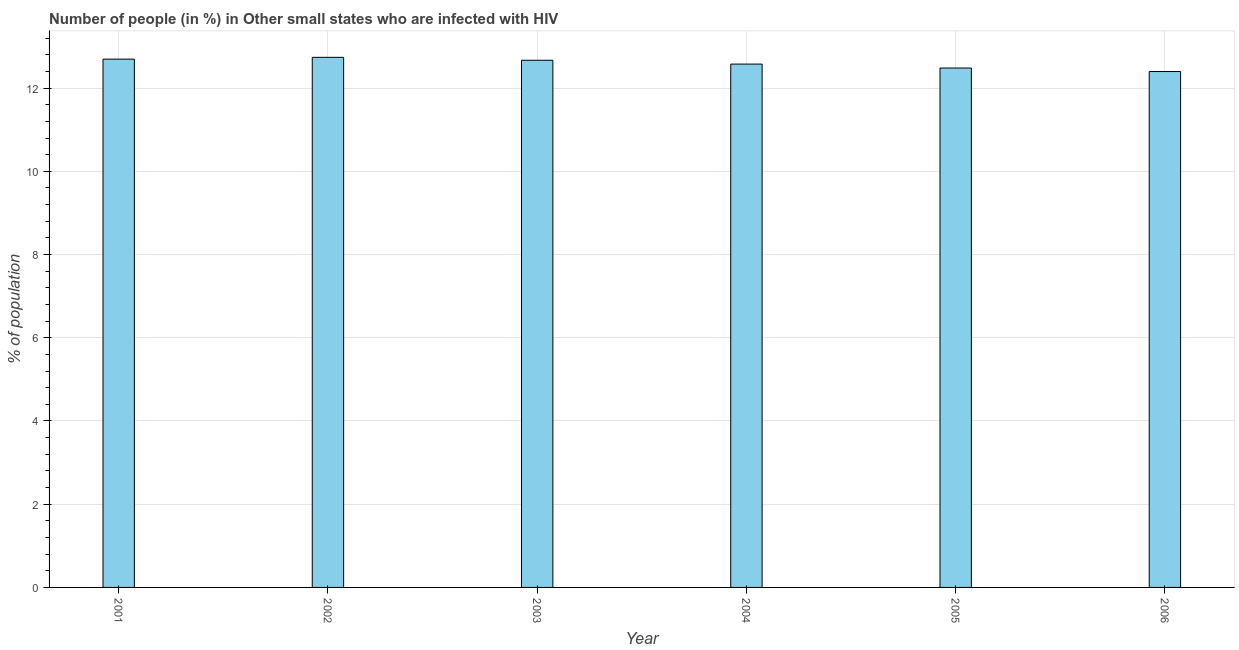Does the graph contain grids?
Keep it short and to the point. Yes. What is the title of the graph?
Ensure brevity in your answer.  Number of people (in %) in Other small states who are infected with HIV. What is the label or title of the X-axis?
Ensure brevity in your answer.  Year. What is the label or title of the Y-axis?
Provide a short and direct response. % of population. What is the number of people infected with hiv in 2001?
Your response must be concise. 12.7. Across all years, what is the maximum number of people infected with hiv?
Ensure brevity in your answer.  12.74. Across all years, what is the minimum number of people infected with hiv?
Your answer should be very brief. 12.4. In which year was the number of people infected with hiv minimum?
Your answer should be compact. 2006. What is the sum of the number of people infected with hiv?
Your answer should be compact. 75.56. What is the difference between the number of people infected with hiv in 2005 and 2006?
Your answer should be compact. 0.08. What is the average number of people infected with hiv per year?
Give a very brief answer. 12.59. What is the median number of people infected with hiv?
Provide a succinct answer. 12.62. In how many years, is the number of people infected with hiv greater than 4.4 %?
Ensure brevity in your answer.  6. Is the number of people infected with hiv in 2004 less than that in 2005?
Ensure brevity in your answer.  No. Is the difference between the number of people infected with hiv in 2001 and 2006 greater than the difference between any two years?
Make the answer very short. No. What is the difference between the highest and the second highest number of people infected with hiv?
Ensure brevity in your answer.  0.04. What is the difference between the highest and the lowest number of people infected with hiv?
Your answer should be very brief. 0.34. In how many years, is the number of people infected with hiv greater than the average number of people infected with hiv taken over all years?
Your answer should be very brief. 3. How many bars are there?
Make the answer very short. 6. Are all the bars in the graph horizontal?
Provide a short and direct response. No. How many years are there in the graph?
Provide a short and direct response. 6. What is the difference between two consecutive major ticks on the Y-axis?
Offer a very short reply. 2. What is the % of population of 2001?
Ensure brevity in your answer.  12.7. What is the % of population in 2002?
Your response must be concise. 12.74. What is the % of population of 2003?
Offer a terse response. 12.67. What is the % of population in 2004?
Provide a succinct answer. 12.58. What is the % of population in 2005?
Ensure brevity in your answer.  12.48. What is the % of population of 2006?
Give a very brief answer. 12.4. What is the difference between the % of population in 2001 and 2002?
Offer a terse response. -0.04. What is the difference between the % of population in 2001 and 2003?
Offer a terse response. 0.03. What is the difference between the % of population in 2001 and 2004?
Provide a short and direct response. 0.12. What is the difference between the % of population in 2001 and 2005?
Provide a succinct answer. 0.21. What is the difference between the % of population in 2001 and 2006?
Your answer should be compact. 0.3. What is the difference between the % of population in 2002 and 2003?
Keep it short and to the point. 0.07. What is the difference between the % of population in 2002 and 2004?
Your response must be concise. 0.16. What is the difference between the % of population in 2002 and 2005?
Make the answer very short. 0.26. What is the difference between the % of population in 2002 and 2006?
Offer a terse response. 0.34. What is the difference between the % of population in 2003 and 2004?
Provide a short and direct response. 0.09. What is the difference between the % of population in 2003 and 2005?
Keep it short and to the point. 0.19. What is the difference between the % of population in 2003 and 2006?
Your response must be concise. 0.27. What is the difference between the % of population in 2004 and 2005?
Offer a terse response. 0.09. What is the difference between the % of population in 2004 and 2006?
Your response must be concise. 0.18. What is the difference between the % of population in 2005 and 2006?
Offer a very short reply. 0.08. What is the ratio of the % of population in 2001 to that in 2002?
Keep it short and to the point. 1. What is the ratio of the % of population in 2001 to that in 2003?
Your answer should be compact. 1. What is the ratio of the % of population in 2001 to that in 2004?
Provide a succinct answer. 1.01. What is the ratio of the % of population in 2001 to that in 2005?
Offer a terse response. 1.02. What is the ratio of the % of population in 2001 to that in 2006?
Offer a terse response. 1.02. What is the ratio of the % of population in 2002 to that in 2005?
Make the answer very short. 1.02. What is the ratio of the % of population in 2002 to that in 2006?
Your response must be concise. 1.03. What is the ratio of the % of population in 2003 to that in 2004?
Give a very brief answer. 1.01. What is the ratio of the % of population in 2003 to that in 2005?
Make the answer very short. 1.01. What is the ratio of the % of population in 2003 to that in 2006?
Your answer should be compact. 1.02. What is the ratio of the % of population in 2004 to that in 2005?
Make the answer very short. 1.01. What is the ratio of the % of population in 2004 to that in 2006?
Give a very brief answer. 1.01. 